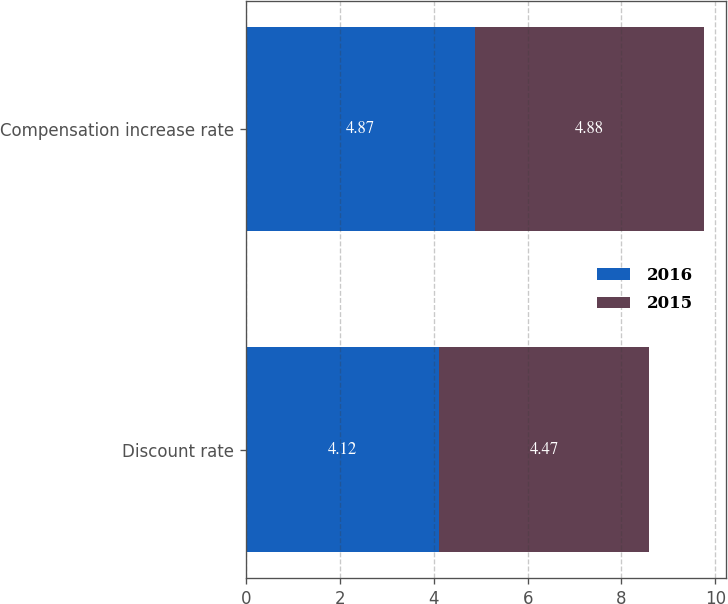<chart> <loc_0><loc_0><loc_500><loc_500><stacked_bar_chart><ecel><fcel>Discount rate<fcel>Compensation increase rate<nl><fcel>2016<fcel>4.12<fcel>4.87<nl><fcel>2015<fcel>4.47<fcel>4.88<nl></chart> 